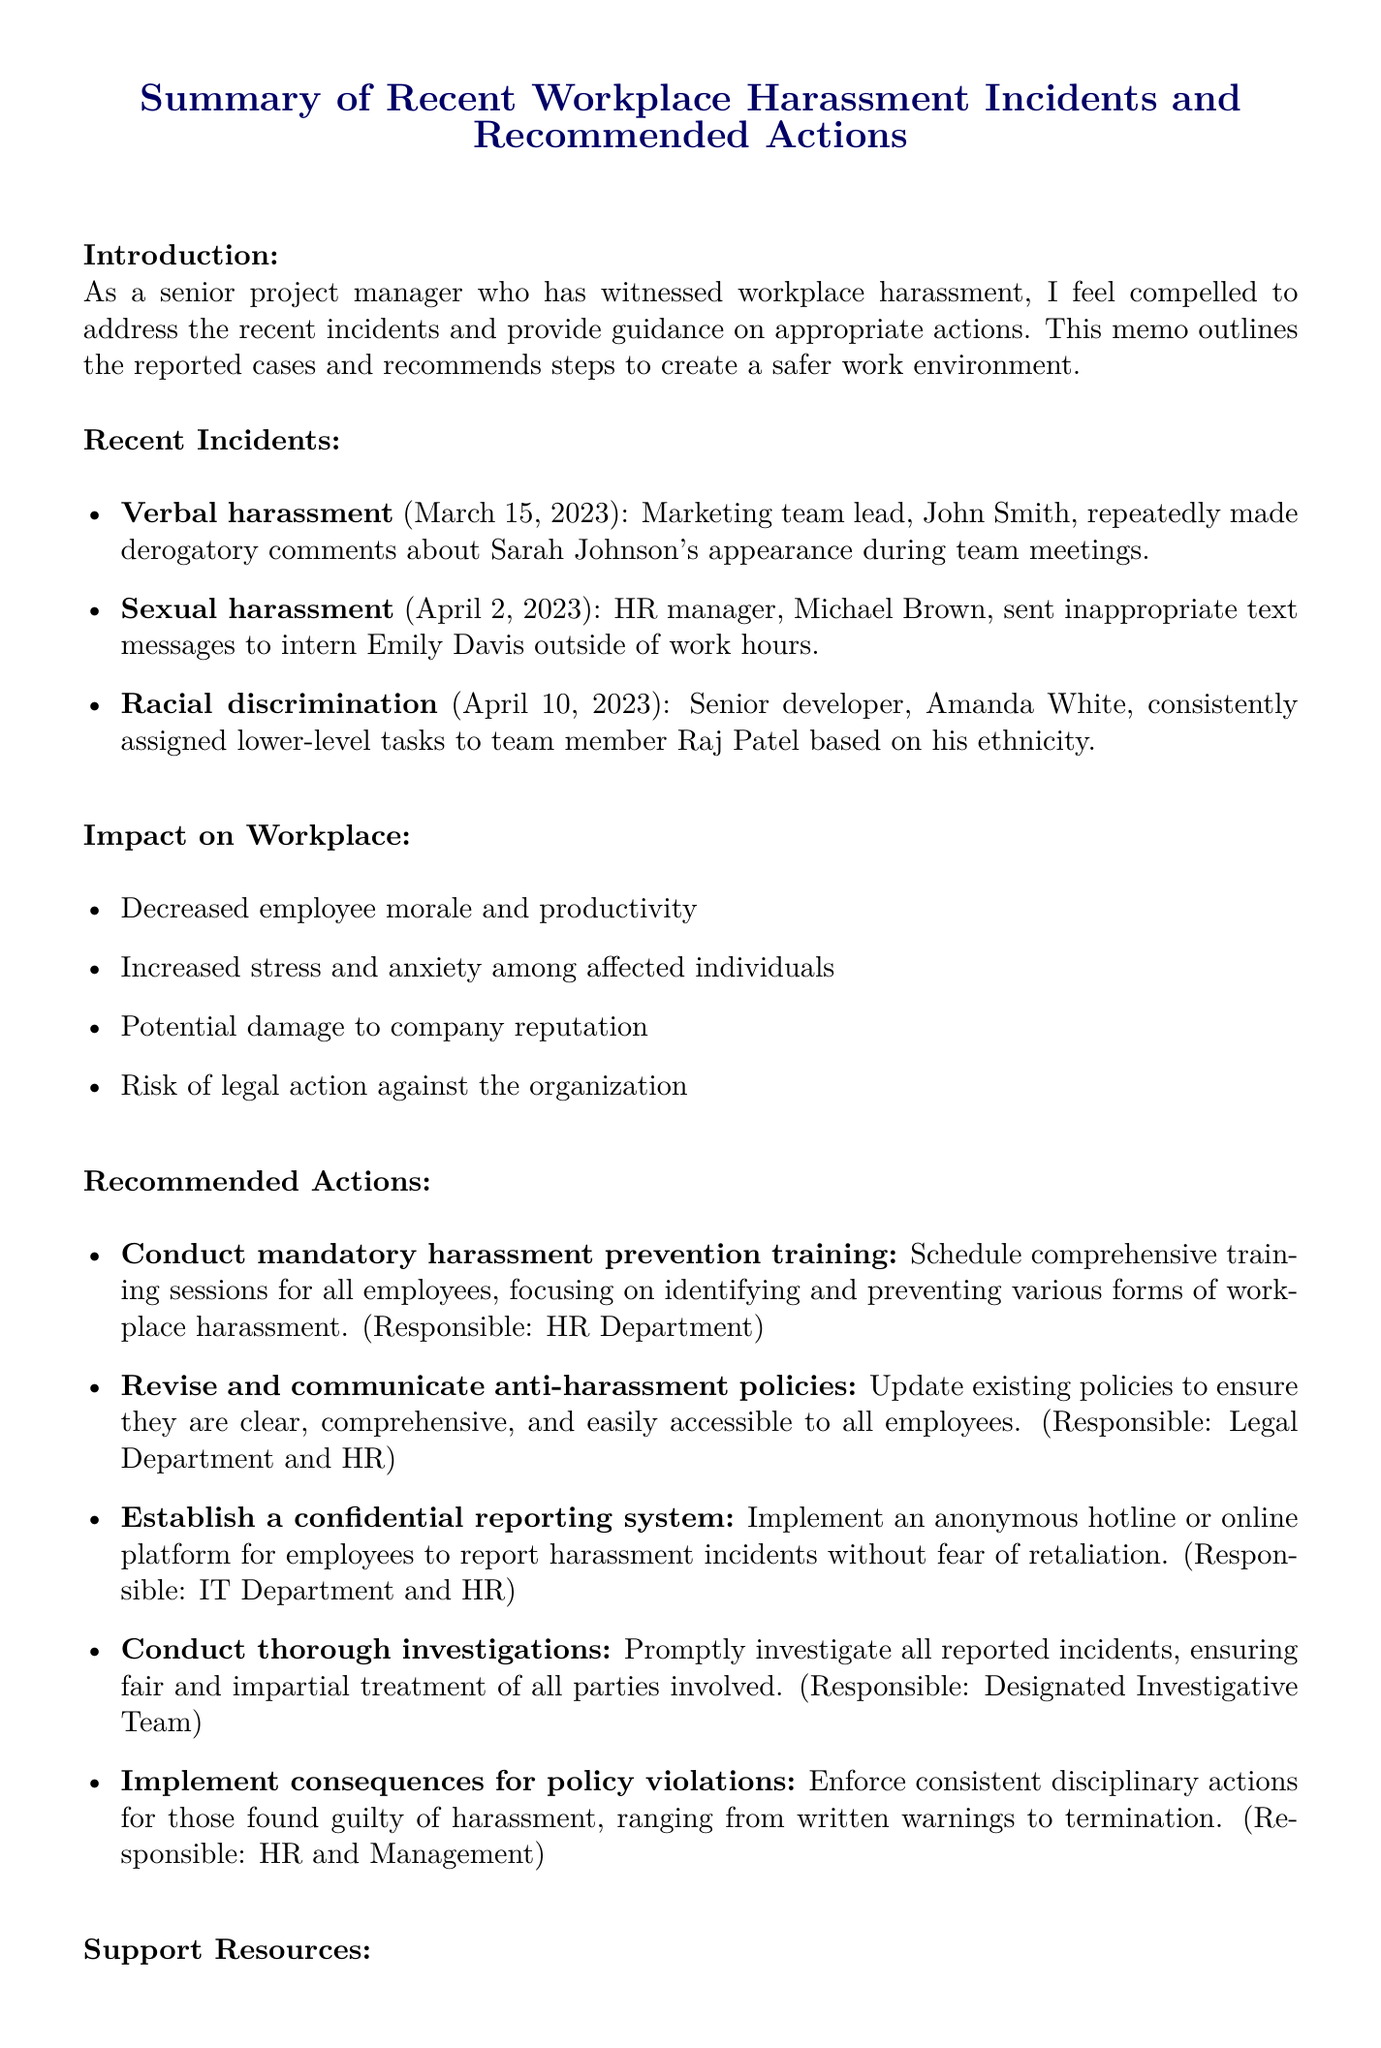what is the title of the memo? The title summarizes the content and purpose of the document, which focuses on recent workplace harassment incidents and recommendations.
Answer: Summary of Recent Workplace Harassment Incidents and Recommended Actions how many recent incidents are reported? The document lists several recent incidents of workplace harassment, indicating the number of cases reported.
Answer: 3 who is the HR manager involved in an incident? The document provides the names and roles of individuals involved in reported incidents of workplace harassment.
Answer: Michael Brown what type of harassment did John Smith commit? The document categorizes incidents of harassment, specifying the nature of John's behavior towards Sarah.
Answer: Verbal harassment which department is responsible for conducting investigations? The document assigns responsibility for investigating reported incidents to a specific team within the organization.
Answer: Designated Investigative Team name one support resource available to employees. The document lists resources designed to support employees facing workplace issues, providing information on available help.
Answer: Employee Assistance Program (EAP) what action involves revising existing policies? The document outlines various recommended actions aimed at addressing workplace harassment and improving policies.
Answer: Revise and communicate anti-harassment policies what is one potential impact of harassment on the workplace? The document outlines several negative consequences that workplace harassment can have on the organization and its employees.
Answer: Decreased employee morale and productivity which incident occurred on April 10, 2023? The document lists incidents by date, allowing for identification of specific cases based on their occurrence.
Answer: Racial discrimination 